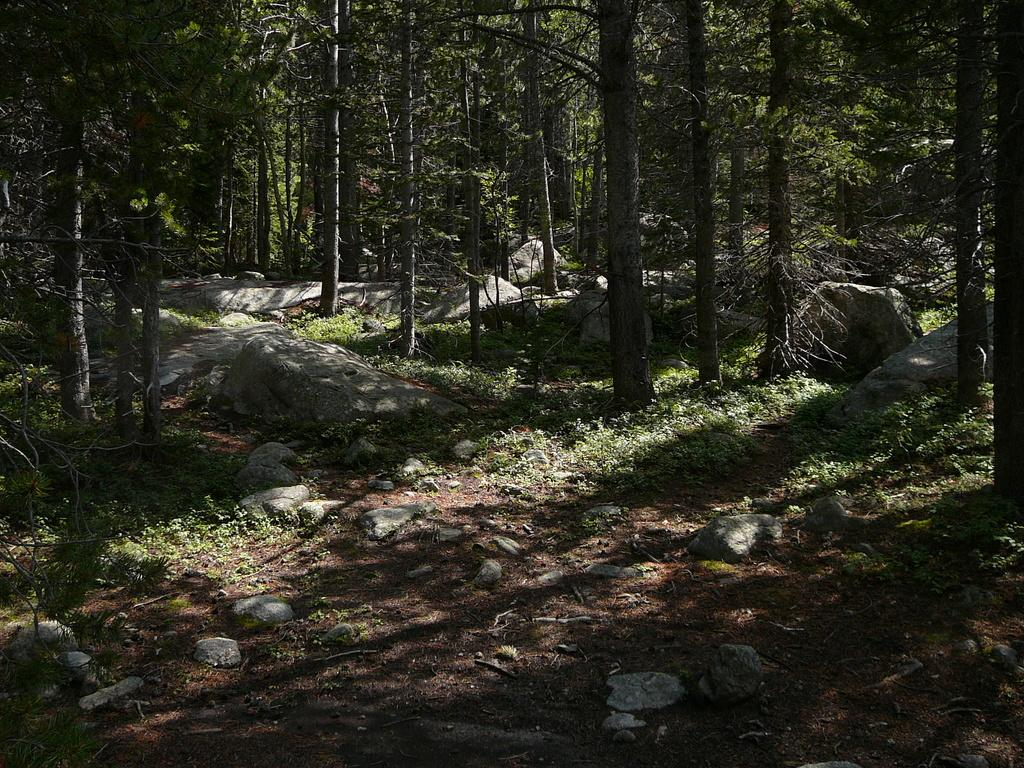What type of vegetation is present in the image? There are many trees and plants in the image. Are there any other natural elements visible in the image? Yes, there are rocks in the image. What type of stone is being used to create a smile in the image? There is no stone or smile present in the image; it features trees, plants, and rocks. 